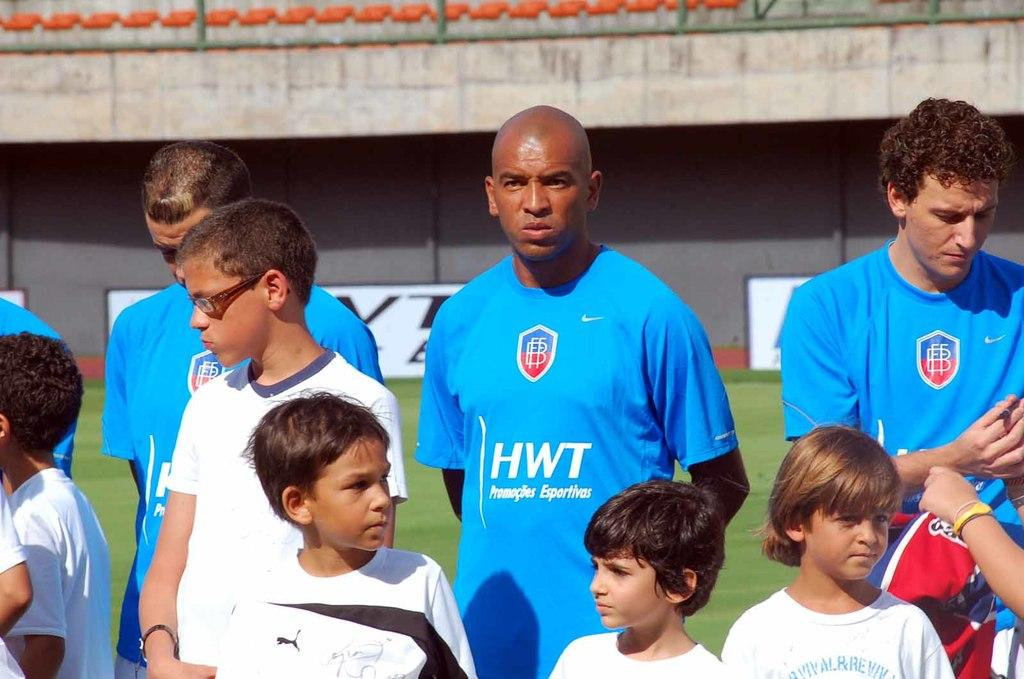<image>
Create a compact narrative representing the image presented. Some men are wearing a jersey sponsored by Promocoes Esportivas. 